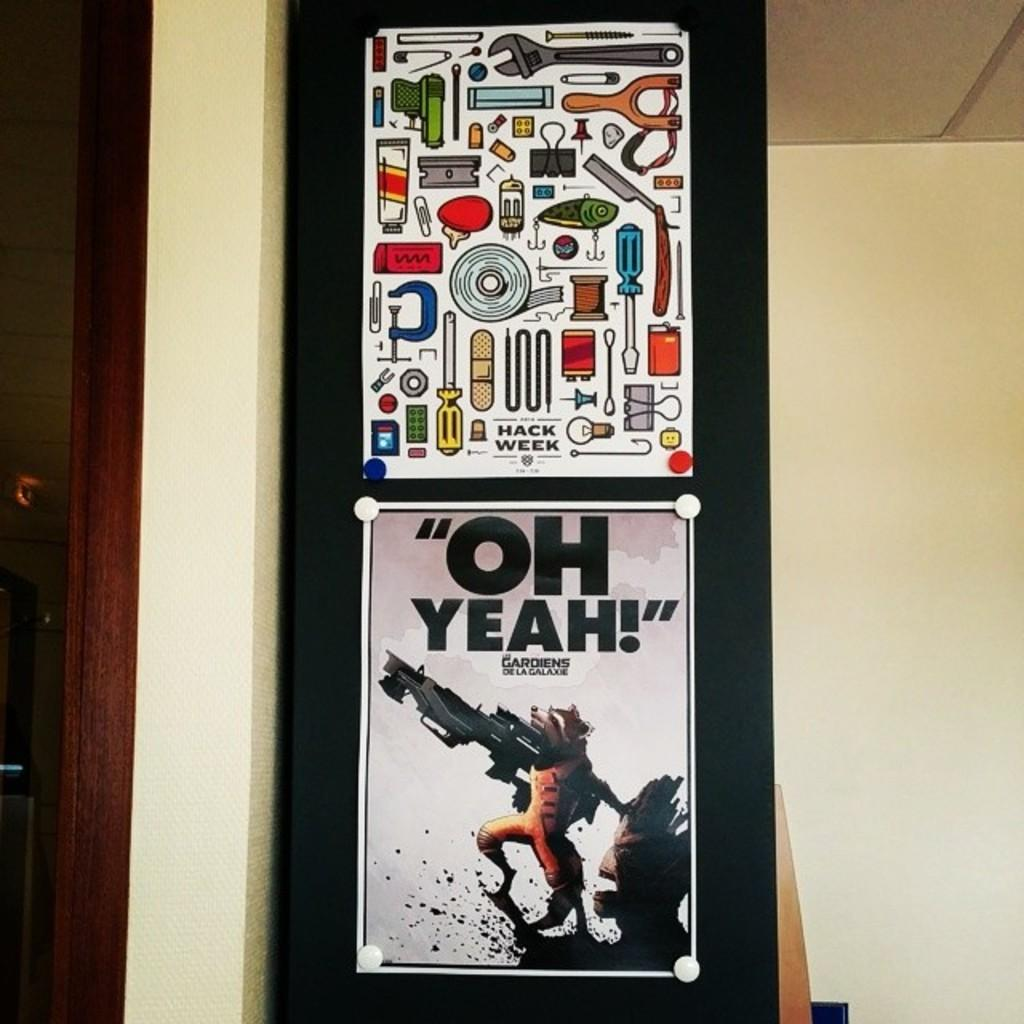<image>
Write a terse but informative summary of the picture. Two posters on a black wall one with an animal with writing oh yeah. 